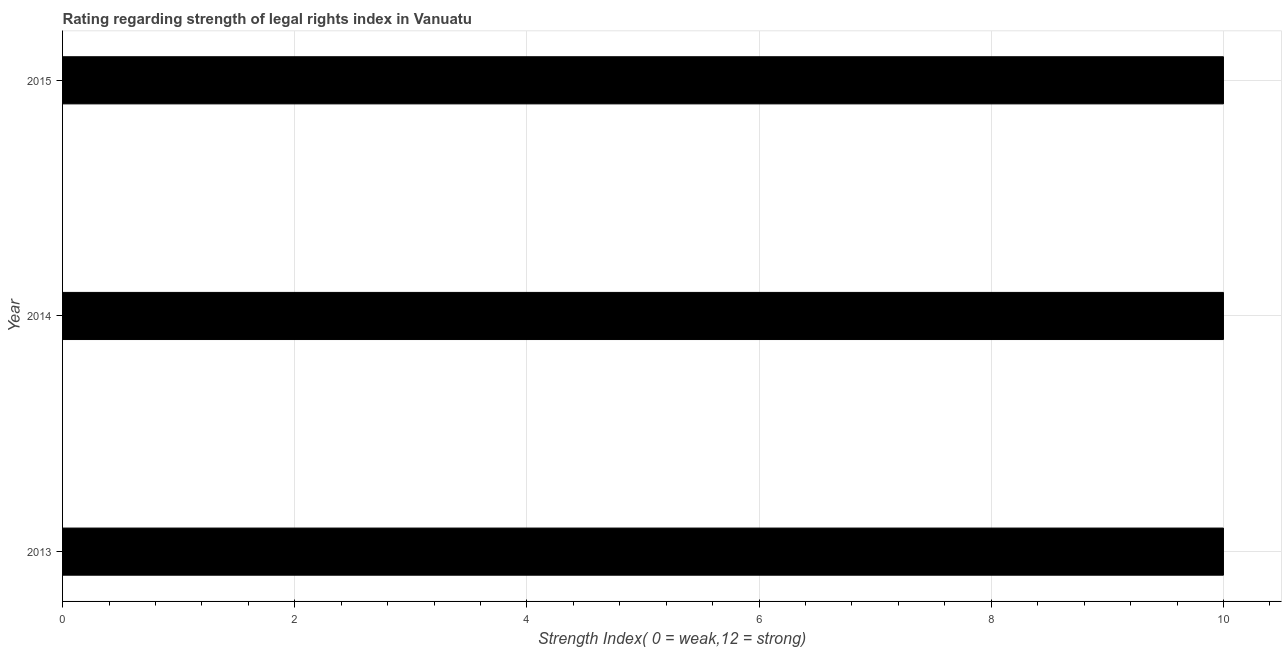Does the graph contain any zero values?
Keep it short and to the point. No. Does the graph contain grids?
Your answer should be compact. Yes. What is the title of the graph?
Keep it short and to the point. Rating regarding strength of legal rights index in Vanuatu. What is the label or title of the X-axis?
Your answer should be very brief. Strength Index( 0 = weak,12 = strong). What is the label or title of the Y-axis?
Provide a succinct answer. Year. What is the strength of legal rights index in 2013?
Offer a terse response. 10. Across all years, what is the minimum strength of legal rights index?
Provide a short and direct response. 10. What is the sum of the strength of legal rights index?
Provide a succinct answer. 30. What is the difference between the strength of legal rights index in 2014 and 2015?
Make the answer very short. 0. What is the average strength of legal rights index per year?
Offer a terse response. 10. In how many years, is the strength of legal rights index greater than 4.4 ?
Keep it short and to the point. 3. What is the ratio of the strength of legal rights index in 2013 to that in 2015?
Give a very brief answer. 1. What is the difference between the highest and the second highest strength of legal rights index?
Offer a very short reply. 0. Is the sum of the strength of legal rights index in 2013 and 2014 greater than the maximum strength of legal rights index across all years?
Provide a short and direct response. Yes. How many bars are there?
Give a very brief answer. 3. How many years are there in the graph?
Give a very brief answer. 3. What is the difference between two consecutive major ticks on the X-axis?
Keep it short and to the point. 2. What is the Strength Index( 0 = weak,12 = strong) of 2014?
Your answer should be very brief. 10. What is the difference between the Strength Index( 0 = weak,12 = strong) in 2013 and 2014?
Your response must be concise. 0. What is the difference between the Strength Index( 0 = weak,12 = strong) in 2013 and 2015?
Make the answer very short. 0. What is the difference between the Strength Index( 0 = weak,12 = strong) in 2014 and 2015?
Offer a terse response. 0. What is the ratio of the Strength Index( 0 = weak,12 = strong) in 2013 to that in 2014?
Keep it short and to the point. 1. What is the ratio of the Strength Index( 0 = weak,12 = strong) in 2013 to that in 2015?
Provide a succinct answer. 1. 